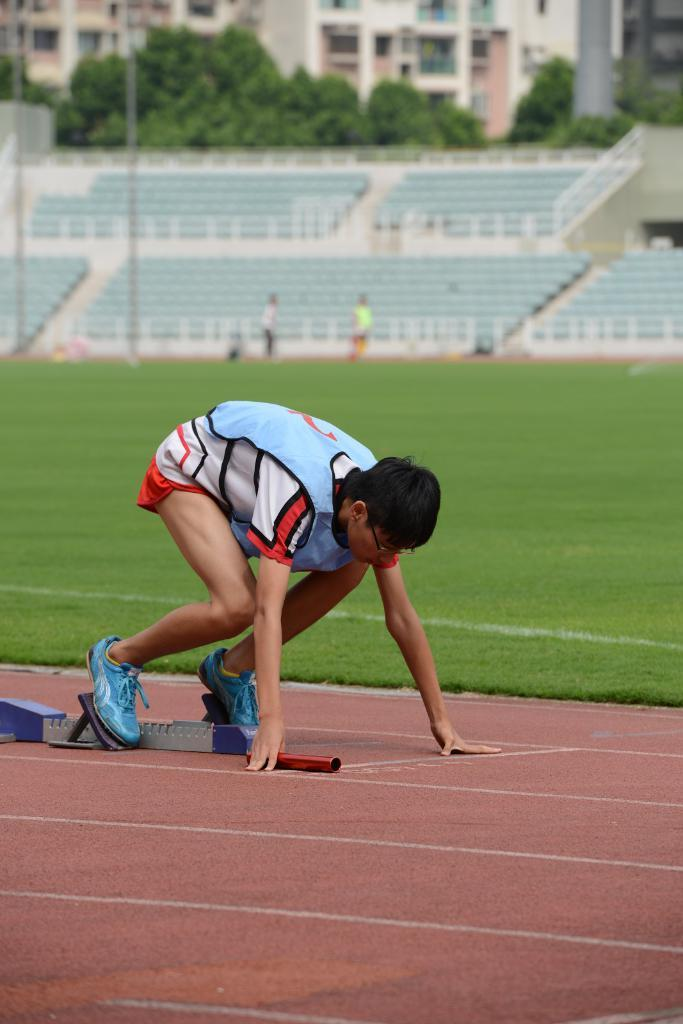What is the main subject in the center of the image? There is a person on the ground in the center of the image. What can be seen in the background of the image? There are persons, chairs, fencing, a building, trees, and grass in the background of the image. How many people are visible in the image? There is one person in the center of the image and at least one person in the background, so there are at least two people visible. What type of lumber is being used to construct the building in the image? There is no information about the type of lumber used to construct the building in the image. How does the water affect the person on the ground in the image? There is no water present in the image, so it does not affect the person on the ground. 